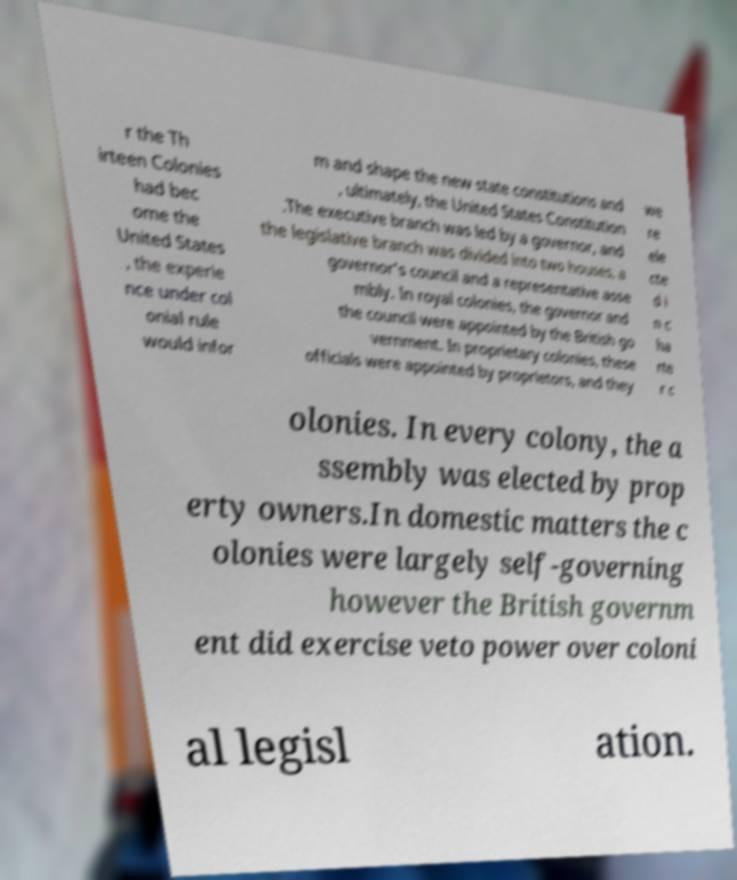There's text embedded in this image that I need extracted. Can you transcribe it verbatim? r the Th irteen Colonies had bec ome the United States , the experie nce under col onial rule would infor m and shape the new state constitutions and , ultimately, the United States Constitution .The executive branch was led by a governor, and the legislative branch was divided into two houses, a governor's council and a representative asse mbly. In royal colonies, the governor and the council were appointed by the British go vernment. In proprietary colonies, these officials were appointed by proprietors, and they we re ele cte d i n c ha rte r c olonies. In every colony, the a ssembly was elected by prop erty owners.In domestic matters the c olonies were largely self-governing however the British governm ent did exercise veto power over coloni al legisl ation. 